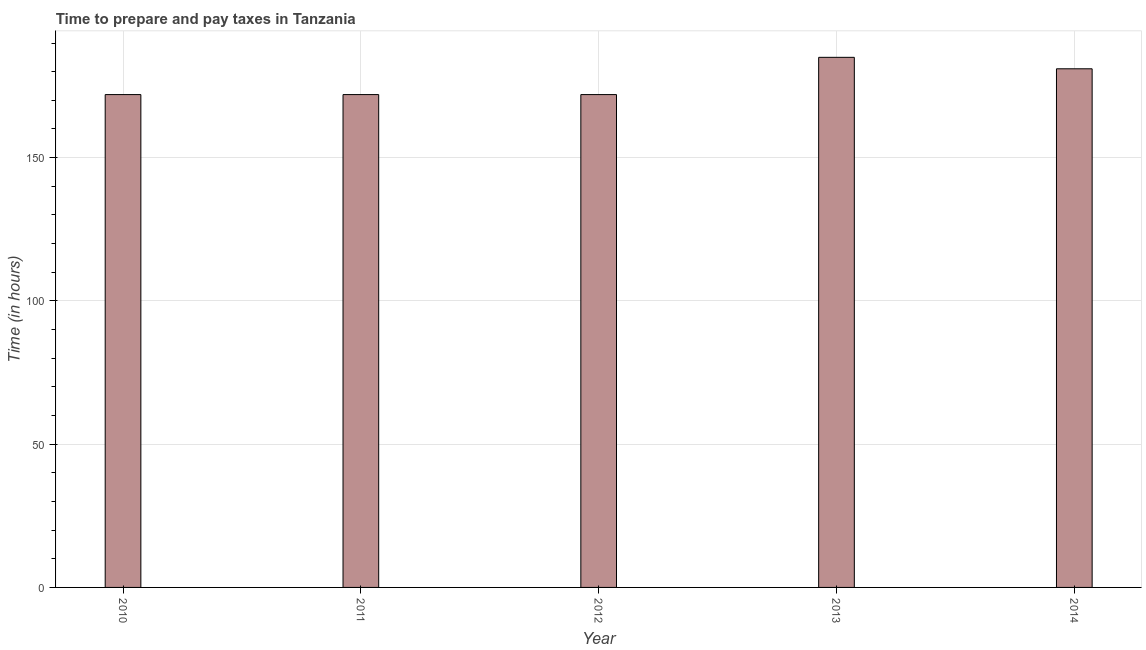Does the graph contain any zero values?
Provide a succinct answer. No. What is the title of the graph?
Give a very brief answer. Time to prepare and pay taxes in Tanzania. What is the label or title of the X-axis?
Give a very brief answer. Year. What is the label or title of the Y-axis?
Offer a very short reply. Time (in hours). What is the time to prepare and pay taxes in 2011?
Give a very brief answer. 172. Across all years, what is the maximum time to prepare and pay taxes?
Your answer should be very brief. 185. Across all years, what is the minimum time to prepare and pay taxes?
Offer a terse response. 172. What is the sum of the time to prepare and pay taxes?
Make the answer very short. 882. What is the difference between the time to prepare and pay taxes in 2010 and 2012?
Your response must be concise. 0. What is the average time to prepare and pay taxes per year?
Make the answer very short. 176. What is the median time to prepare and pay taxes?
Your answer should be very brief. 172. What is the ratio of the time to prepare and pay taxes in 2010 to that in 2012?
Offer a very short reply. 1. Is the time to prepare and pay taxes in 2011 less than that in 2012?
Offer a terse response. No. What is the difference between the highest and the second highest time to prepare and pay taxes?
Keep it short and to the point. 4. Is the sum of the time to prepare and pay taxes in 2013 and 2014 greater than the maximum time to prepare and pay taxes across all years?
Keep it short and to the point. Yes. What is the difference between the highest and the lowest time to prepare and pay taxes?
Make the answer very short. 13. In how many years, is the time to prepare and pay taxes greater than the average time to prepare and pay taxes taken over all years?
Offer a very short reply. 2. How many bars are there?
Offer a very short reply. 5. Are all the bars in the graph horizontal?
Your answer should be compact. No. How many years are there in the graph?
Offer a very short reply. 5. Are the values on the major ticks of Y-axis written in scientific E-notation?
Your response must be concise. No. What is the Time (in hours) in 2010?
Offer a terse response. 172. What is the Time (in hours) of 2011?
Provide a succinct answer. 172. What is the Time (in hours) of 2012?
Offer a terse response. 172. What is the Time (in hours) in 2013?
Offer a terse response. 185. What is the Time (in hours) in 2014?
Keep it short and to the point. 181. What is the difference between the Time (in hours) in 2010 and 2011?
Offer a very short reply. 0. What is the difference between the Time (in hours) in 2010 and 2012?
Make the answer very short. 0. What is the difference between the Time (in hours) in 2011 and 2012?
Give a very brief answer. 0. What is the difference between the Time (in hours) in 2011 and 2013?
Keep it short and to the point. -13. What is the difference between the Time (in hours) in 2011 and 2014?
Your answer should be compact. -9. What is the difference between the Time (in hours) in 2013 and 2014?
Make the answer very short. 4. What is the ratio of the Time (in hours) in 2010 to that in 2011?
Offer a very short reply. 1. What is the ratio of the Time (in hours) in 2010 to that in 2012?
Offer a very short reply. 1. What is the ratio of the Time (in hours) in 2011 to that in 2012?
Your answer should be compact. 1. What is the ratio of the Time (in hours) in 2011 to that in 2013?
Give a very brief answer. 0.93. What is the ratio of the Time (in hours) in 2011 to that in 2014?
Provide a short and direct response. 0.95. What is the ratio of the Time (in hours) in 2012 to that in 2014?
Your answer should be compact. 0.95. What is the ratio of the Time (in hours) in 2013 to that in 2014?
Give a very brief answer. 1.02. 